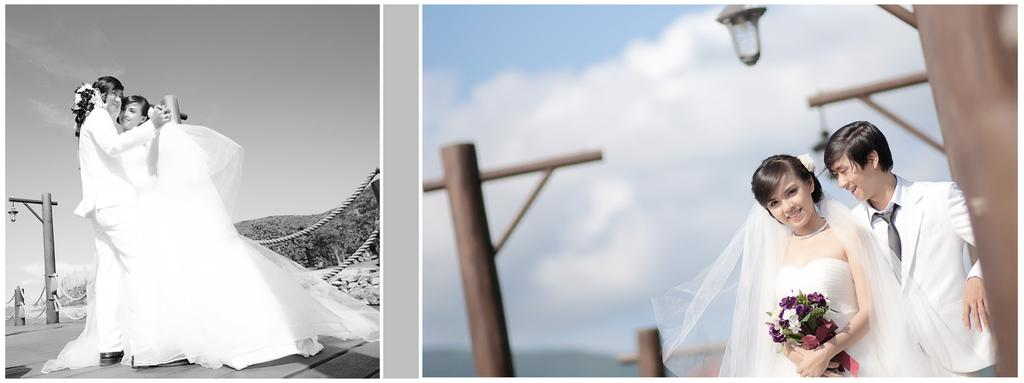What is the main subject of the picture? The main subject of the picture is a collage image of a couple. What is the lady holding in the image? The lady is holding flowers in the image. What type of structures can be seen in the image? There are poles in the image. What can be used for illumination in the image? There are lights in the image. What are the ropes used for in the image? The ropes are present in the image, but their specific purpose is not clear. What type of natural landscape is visible in the image? Mountains are visible in the image. What part of the sky is visible in the image? The sky is visible in the image. Where is the hospital located in the image? There is no hospital present in the image. What type of furniture can be seen on the desk in the image? There is no desk present in the image. 